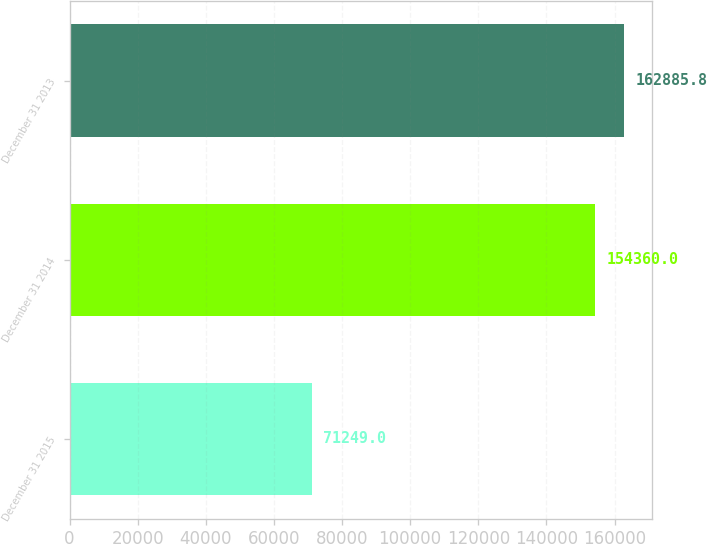Convert chart. <chart><loc_0><loc_0><loc_500><loc_500><bar_chart><fcel>December 31 2015<fcel>December 31 2014<fcel>December 31 2013<nl><fcel>71249<fcel>154360<fcel>162886<nl></chart> 